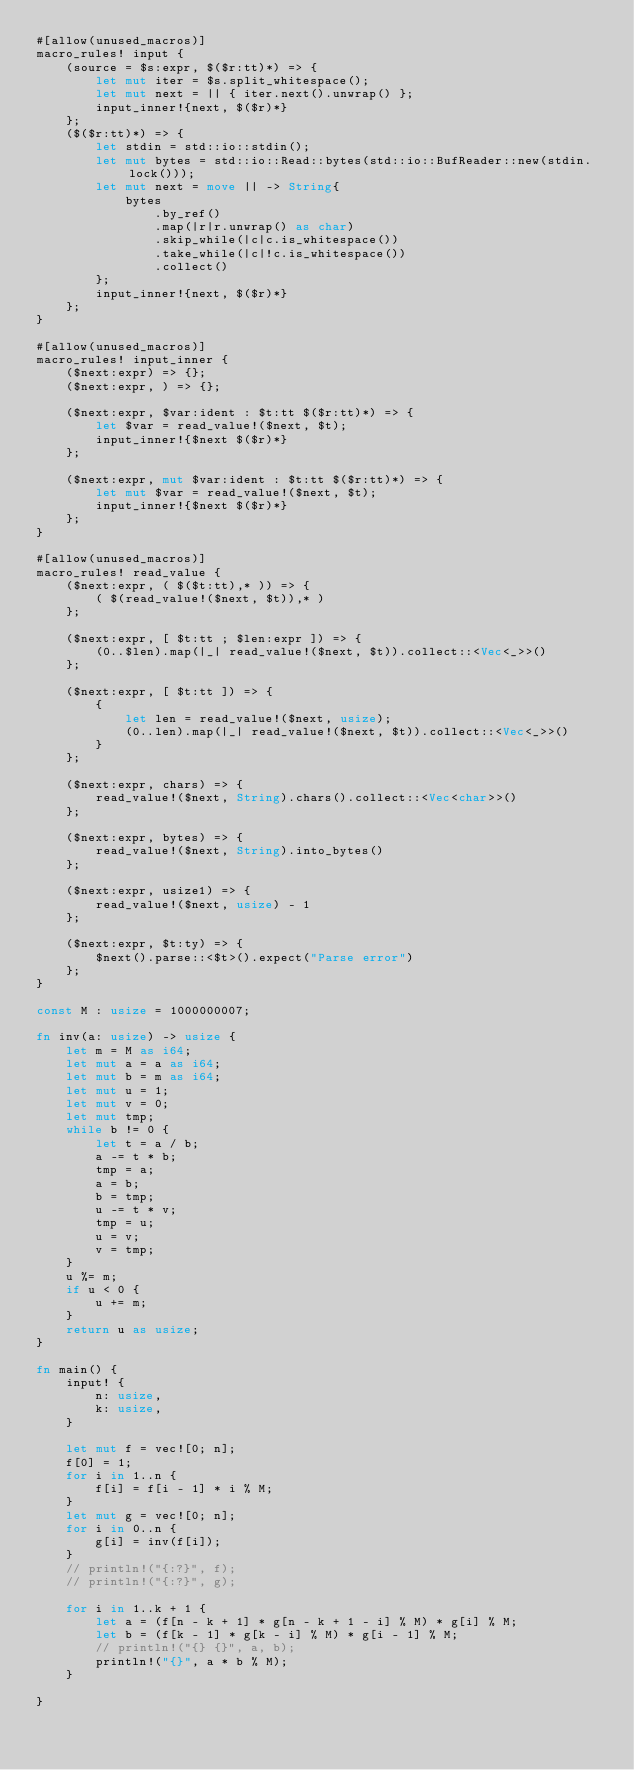<code> <loc_0><loc_0><loc_500><loc_500><_Rust_>#[allow(unused_macros)]
macro_rules! input {
    (source = $s:expr, $($r:tt)*) => {
        let mut iter = $s.split_whitespace();
        let mut next = || { iter.next().unwrap() };
        input_inner!{next, $($r)*}
    };
    ($($r:tt)*) => {
        let stdin = std::io::stdin();
        let mut bytes = std::io::Read::bytes(std::io::BufReader::new(stdin.lock()));
        let mut next = move || -> String{
            bytes
                .by_ref()
                .map(|r|r.unwrap() as char)
                .skip_while(|c|c.is_whitespace())
                .take_while(|c|!c.is_whitespace())
                .collect()
        };
        input_inner!{next, $($r)*}
    };
}

#[allow(unused_macros)]
macro_rules! input_inner {
    ($next:expr) => {};
    ($next:expr, ) => {};

    ($next:expr, $var:ident : $t:tt $($r:tt)*) => {
        let $var = read_value!($next, $t);
        input_inner!{$next $($r)*}
    };

    ($next:expr, mut $var:ident : $t:tt $($r:tt)*) => {
        let mut $var = read_value!($next, $t);
        input_inner!{$next $($r)*}
    };
}

#[allow(unused_macros)]
macro_rules! read_value {
    ($next:expr, ( $($t:tt),* )) => {
        ( $(read_value!($next, $t)),* )
    };

    ($next:expr, [ $t:tt ; $len:expr ]) => {
        (0..$len).map(|_| read_value!($next, $t)).collect::<Vec<_>>()
    };

    ($next:expr, [ $t:tt ]) => {
        {
            let len = read_value!($next, usize);
            (0..len).map(|_| read_value!($next, $t)).collect::<Vec<_>>()
        }
    };

    ($next:expr, chars) => {
        read_value!($next, String).chars().collect::<Vec<char>>()
    };

    ($next:expr, bytes) => {
        read_value!($next, String).into_bytes()
    };

    ($next:expr, usize1) => {
        read_value!($next, usize) - 1
    };

    ($next:expr, $t:ty) => {
        $next().parse::<$t>().expect("Parse error")
    };
}

const M : usize = 1000000007;

fn inv(a: usize) -> usize {
    let m = M as i64;
    let mut a = a as i64;
    let mut b = m as i64;
    let mut u = 1;
    let mut v = 0;
    let mut tmp;
    while b != 0 {
        let t = a / b;
        a -= t * b;
        tmp = a;
        a = b;
        b = tmp;
        u -= t * v;
        tmp = u;
        u = v;
        v = tmp;
    }
    u %= m;
    if u < 0 {
        u += m;
    }
    return u as usize;
}

fn main() {
    input! {
        n: usize,
        k: usize,
    }

    let mut f = vec![0; n];
    f[0] = 1;
    for i in 1..n {
        f[i] = f[i - 1] * i % M;
    }
    let mut g = vec![0; n];
    for i in 0..n {
        g[i] = inv(f[i]);
    }
    // println!("{:?}", f);
    // println!("{:?}", g);

    for i in 1..k + 1 {
        let a = (f[n - k + 1] * g[n - k + 1 - i] % M) * g[i] % M;
        let b = (f[k - 1] * g[k - i] % M) * g[i - 1] % M;
        // println!("{} {}", a, b);
        println!("{}", a * b % M);
    }

}
</code> 